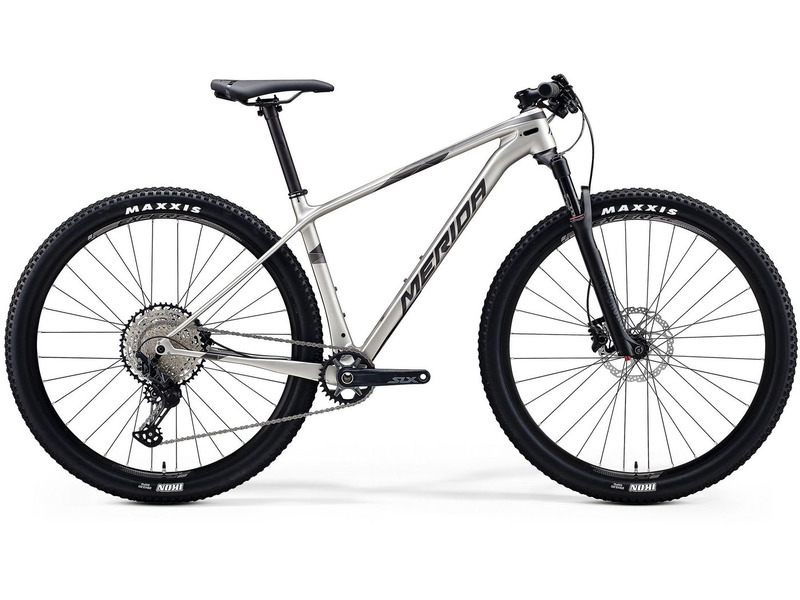How does the design of this bike cater to the needs of competitive racers? The design of this mountain bike is meticulously crafted to cater to the needs of competitive racers, incorporating several key features aimed at enhancing performance, efficiency, and reliability:

1. **Lightweight Frame**: The bike’s frame is made from lightweight materials, such as aluminum or carbon fiber, reducing overall weight and allowing racers to accelerate quickly and maintain high speeds with less effort.

2. **Single Chainring Drivetrain**: The absence of a front derailleur simplifies the drivetrain, reducing weight and minimizing the risk of mechanical issues. This setup also allows for quicker and more precise gear changes, which is crucial in the fast-paced environment of competitive racing.

3. **Front Suspension**: Competitive racers often encounter rough and uneven terrains. The front suspension fork helps absorb shocks and vibrations, ensuring that the rider maintains control and speed, even on technical trails. This feature is especially advantageous in cross-country races where terrain can vary significantly.

4. **High-Performance Tires**: The MAXXIS tires fitted on this bike are designed to provide excellent grip and traction on a variety of surfaces. For competitive racing, tire performance is crucial, as it affects handling, speed, and overall stability.

5. **Optimized Geometry**: The bike’s geometry is tailored for competitive racing, with a focus on providing an aggressive riding position that improves aerodynamics and power transfer. This helps racers maintain endurance and efficiently navigate demanding courses.

6. **Durable Components**: High-quality components, such as the drivetrain, brakes, and wheels, are selected for their durability and reliability under intense conditions. This ensures that the bike can withstand the rigors of competitive racing without failure.

7. **Enhanced Braking System**: Competitive racing demands precise and responsive braking. This bike is equipped with powerful hydraulic disc brakes that offer superior stopping power and modulation, essential for safely navigating technical descents and sudden obstacles.

These design elements come together to create a high-performance mountain bike that meets the specific needs of competitive racers, enabling them to perform at their best and tackle racecourses with confidence and precision. Could you outline a typical training routine for a competitive mountain bike racer using this bike? A typical training routine for a competitive mountain bike racer using this bike would be diverse and demanding, aimed at building endurance, strength, technique, and speed. Here’s an outline of a weekly training plan:

**Monday: Active Recovery**
- Light trail ride or road cycling (1-2 hours)
- Focus on maintaining a steady pace, low intensity
- Gentle stretching and yoga to aid recovery

**Tuesday: Interval Training**
- Warm-up: 30 minutes easy ride
- Main Set: 3 sets of 5 x 3-minute high-intensity intervals with 2 minutes recovery between intervals, and 5 minutes recovery between sets
- Cool-down: 20 minutes easy ride

**Wednesday: Strength Training**
- Warm-up: Light cycling (20 minutes)
- Gym Session: Focus on core, legs, and upper body (squats, deadlifts, lunges, planks, push-ups)
- Cool-down: Light stretching

**Thursday: Skills and Technique**
- Trail ride focused on technical skills (2-3 hours)
- Practice cornering, descending, obstacle negotiation, and line selection
- Include short sprints and accelerations to simulate race conditions

**Friday: Endurance Ride**
- Long trail ride (4-5 hours)
- Maintain a moderate, consistent pace
- Incorporate varied terrain to adapt to diverse race conditions

**Saturday: Race Simulation**
- Warm-up: 30 minutes easy ride
- Main Set: 1-2 hours high-intensity ride simulating race conditions (include climbs, descents, technical sections)
- Cool-down: 20 minutes easy ride

**Sunday: Rest Day**
- Complete rest or light activity (gentle walk, stretching)

**Additional Activities:**
- Regular bike maintenance checks to ensure the bike is in optimal condition
- Nutrition planning to fuel training sessions and aid recovery
- Mental training such as visualization techniques and race strategies

This balanced and comprehensive training routine helps in building the necessary physical and mental attributes required for competitive mountain bike racing while utilizing the high-performance features of the bike to their fullest potential. 